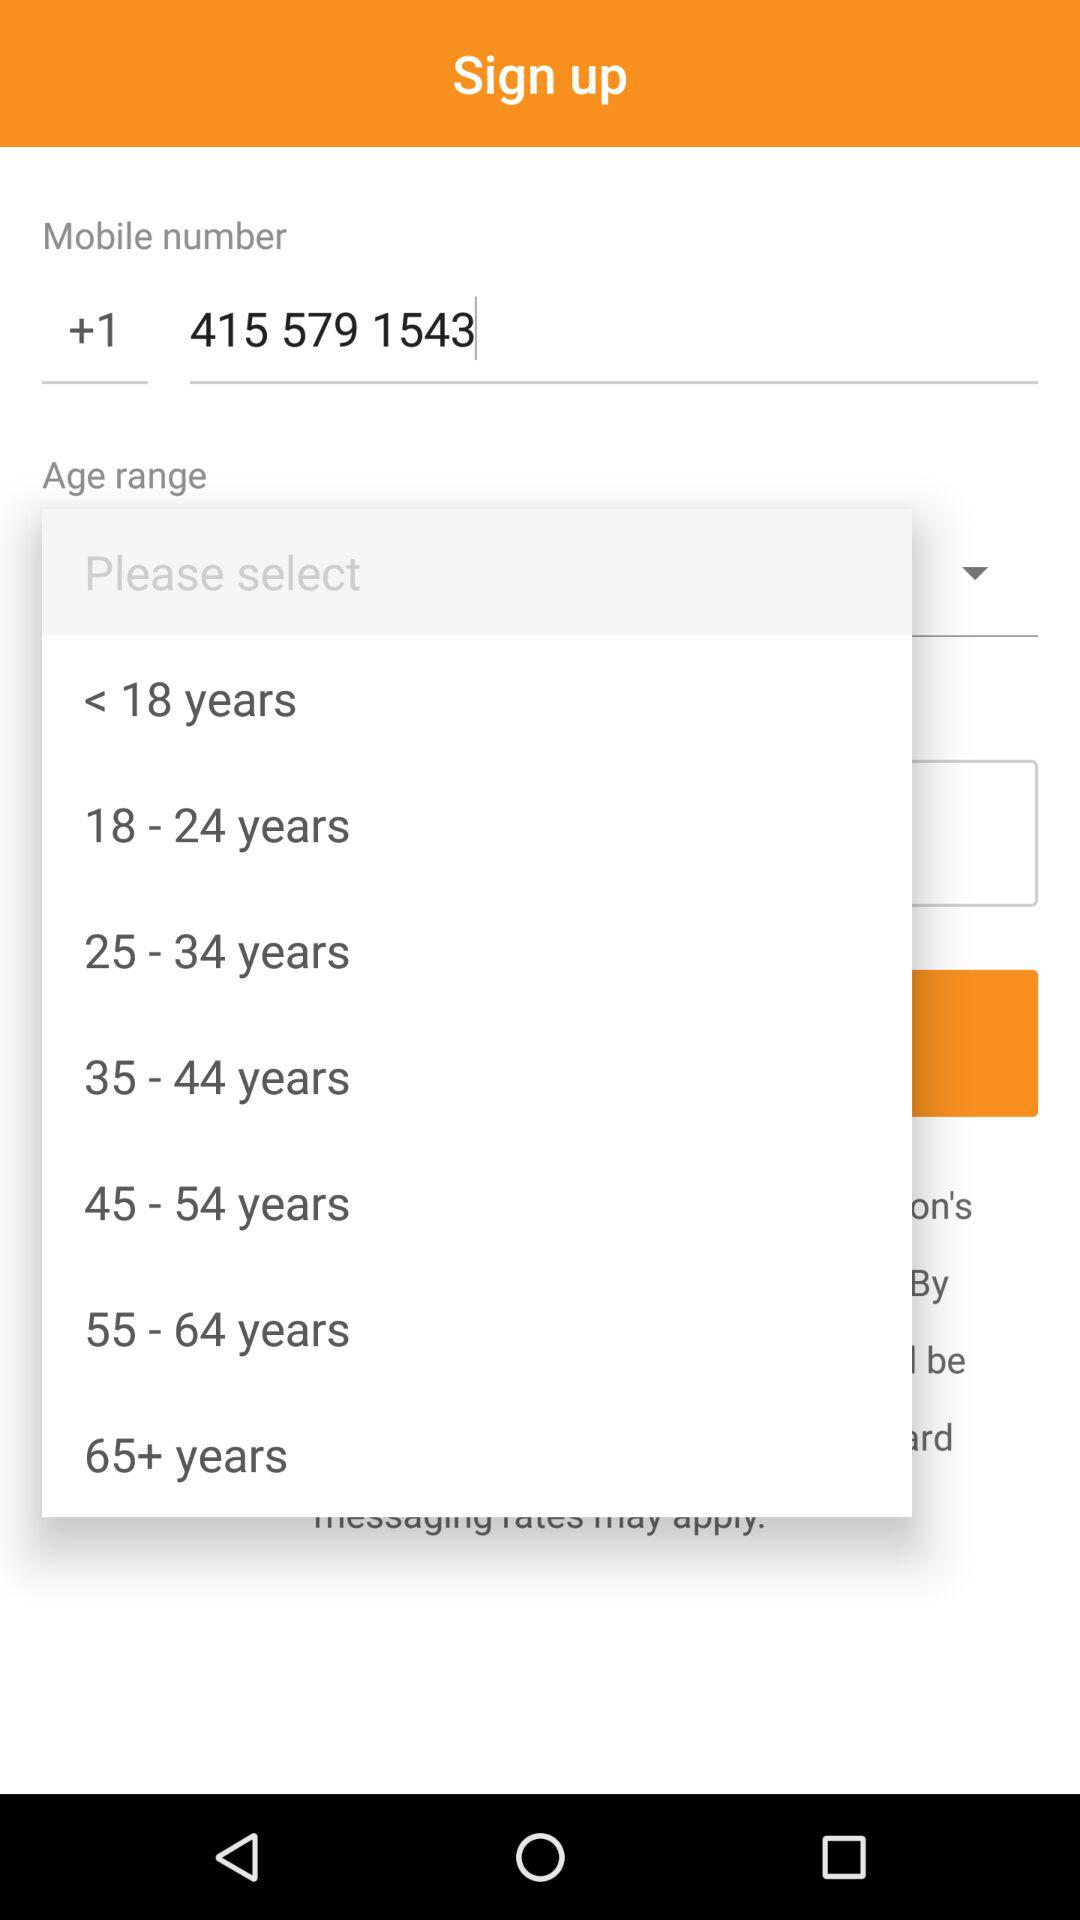What is the mobile number? The mobile number is +1 415 579 1543. 